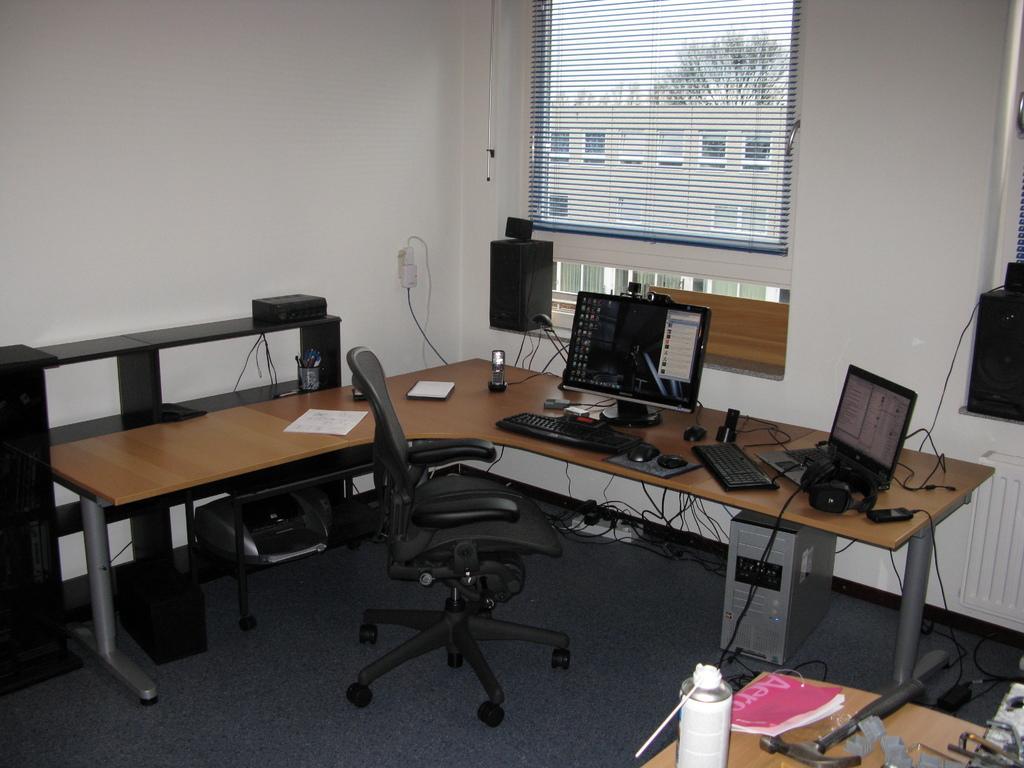In one or two sentences, can you explain what this image depicts? There is a monitor, keyboard, mouse, laptop, headset, mobile, book, paper, and other items on the table. In front of the table, there is a chair on the floor which is covered with a carpet. In the background, there is a window, wall, a tree and building. Speaker is on the wall of the window. On the right hand side, there are books, tin and some other items on a table. On the left hand side, there is a device on the floor. 